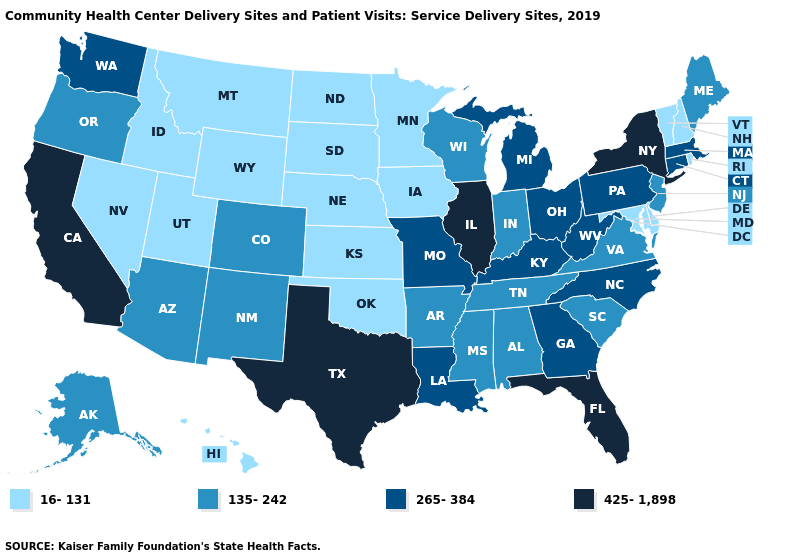Among the states that border Texas , which have the lowest value?
Answer briefly. Oklahoma. Among the states that border Indiana , does Illinois have the lowest value?
Write a very short answer. No. Does the first symbol in the legend represent the smallest category?
Keep it brief. Yes. Name the states that have a value in the range 265-384?
Short answer required. Connecticut, Georgia, Kentucky, Louisiana, Massachusetts, Michigan, Missouri, North Carolina, Ohio, Pennsylvania, Washington, West Virginia. What is the value of Michigan?
Be succinct. 265-384. Does California have the highest value in the USA?
Write a very short answer. Yes. What is the highest value in the MidWest ?
Short answer required. 425-1,898. Does Michigan have the same value as South Dakota?
Write a very short answer. No. What is the value of Missouri?
Be succinct. 265-384. What is the highest value in states that border Idaho?
Quick response, please. 265-384. Name the states that have a value in the range 135-242?
Answer briefly. Alabama, Alaska, Arizona, Arkansas, Colorado, Indiana, Maine, Mississippi, New Jersey, New Mexico, Oregon, South Carolina, Tennessee, Virginia, Wisconsin. What is the highest value in the MidWest ?
Write a very short answer. 425-1,898. What is the lowest value in states that border New York?
Quick response, please. 16-131. Name the states that have a value in the range 265-384?
Be succinct. Connecticut, Georgia, Kentucky, Louisiana, Massachusetts, Michigan, Missouri, North Carolina, Ohio, Pennsylvania, Washington, West Virginia. Which states have the lowest value in the USA?
Short answer required. Delaware, Hawaii, Idaho, Iowa, Kansas, Maryland, Minnesota, Montana, Nebraska, Nevada, New Hampshire, North Dakota, Oklahoma, Rhode Island, South Dakota, Utah, Vermont, Wyoming. 